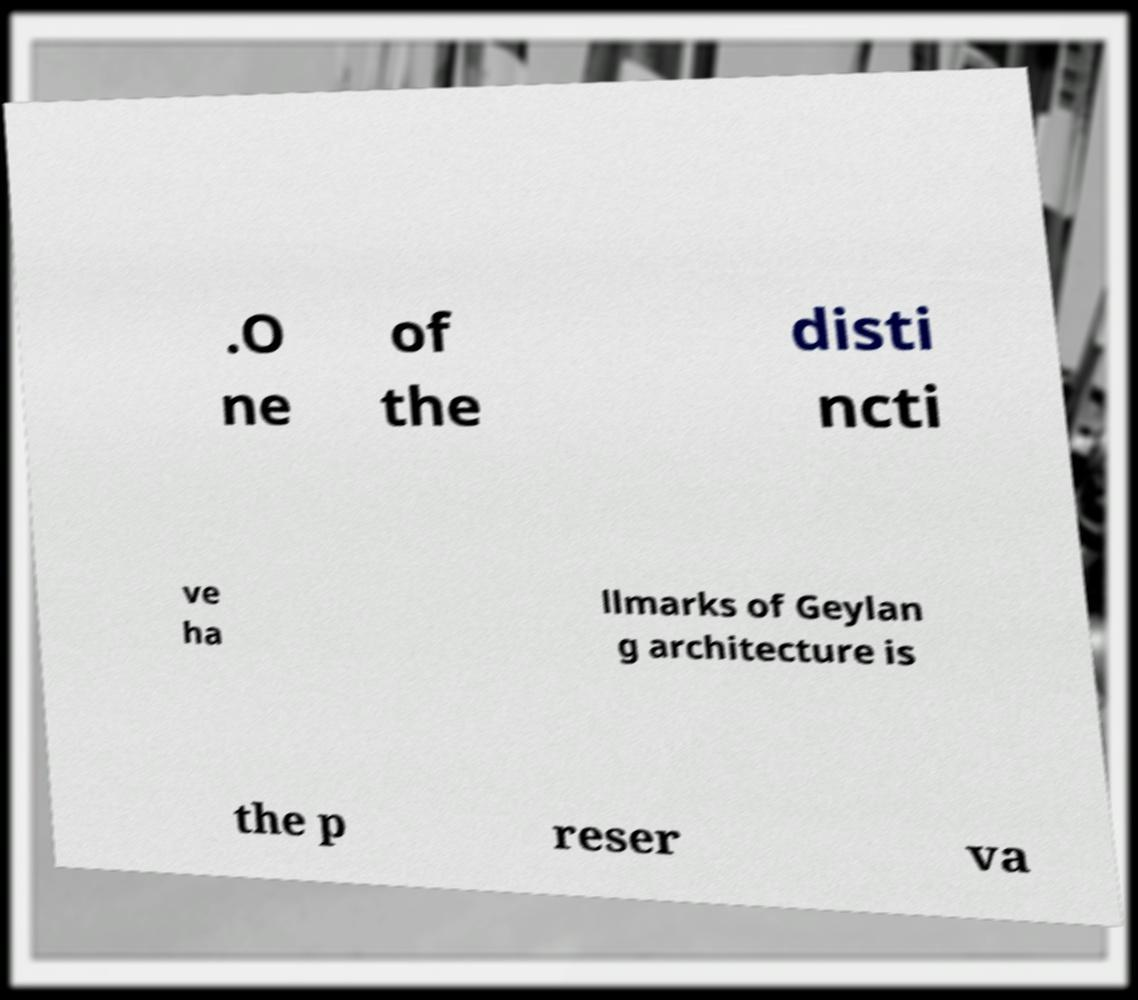Can you accurately transcribe the text from the provided image for me? .O ne of the disti ncti ve ha llmarks of Geylan g architecture is the p reser va 